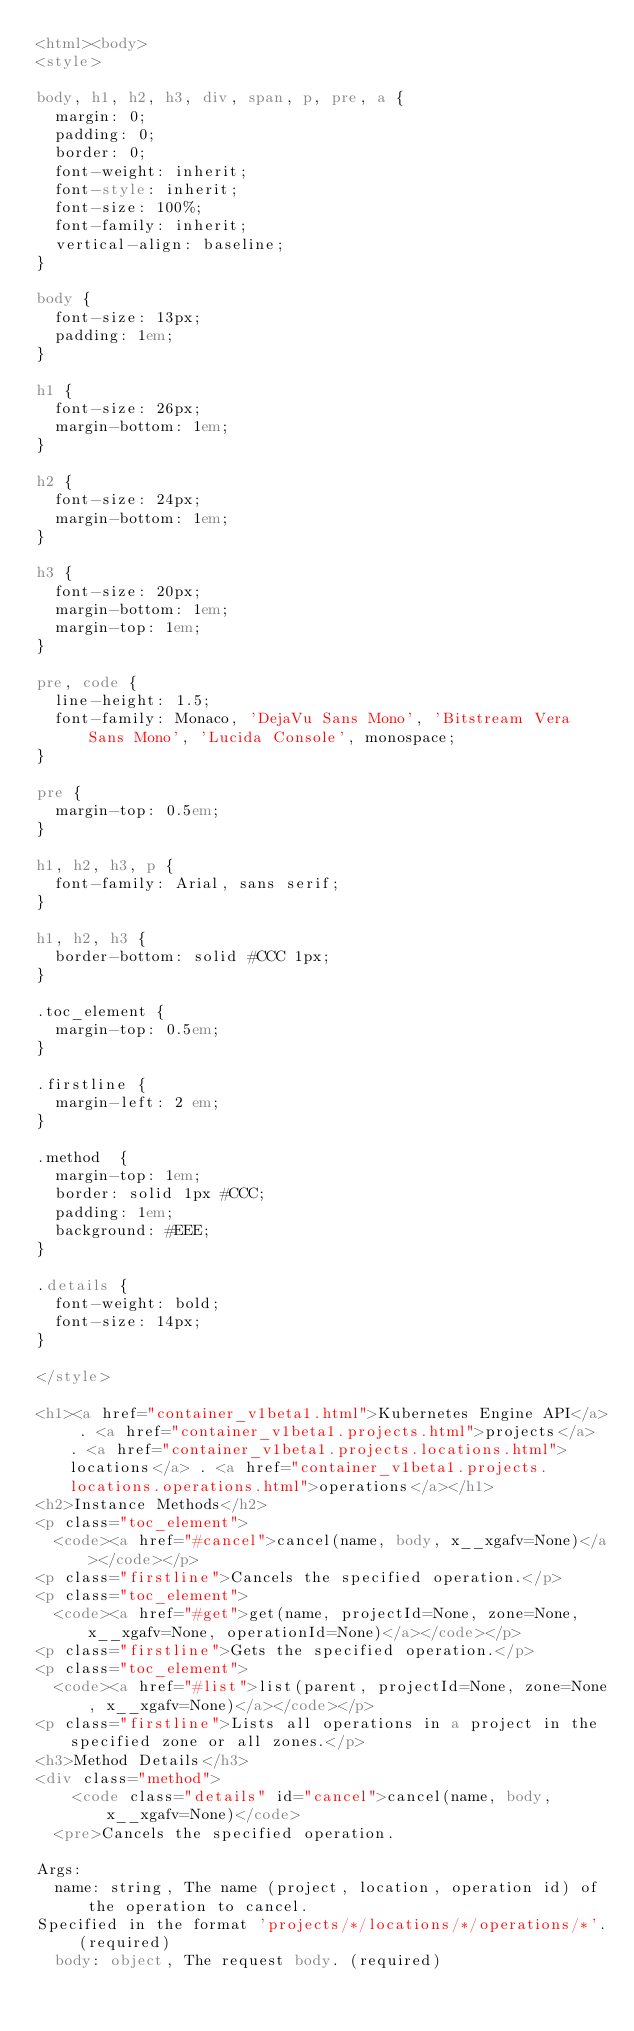Convert code to text. <code><loc_0><loc_0><loc_500><loc_500><_HTML_><html><body>
<style>

body, h1, h2, h3, div, span, p, pre, a {
  margin: 0;
  padding: 0;
  border: 0;
  font-weight: inherit;
  font-style: inherit;
  font-size: 100%;
  font-family: inherit;
  vertical-align: baseline;
}

body {
  font-size: 13px;
  padding: 1em;
}

h1 {
  font-size: 26px;
  margin-bottom: 1em;
}

h2 {
  font-size: 24px;
  margin-bottom: 1em;
}

h3 {
  font-size: 20px;
  margin-bottom: 1em;
  margin-top: 1em;
}

pre, code {
  line-height: 1.5;
  font-family: Monaco, 'DejaVu Sans Mono', 'Bitstream Vera Sans Mono', 'Lucida Console', monospace;
}

pre {
  margin-top: 0.5em;
}

h1, h2, h3, p {
  font-family: Arial, sans serif;
}

h1, h2, h3 {
  border-bottom: solid #CCC 1px;
}

.toc_element {
  margin-top: 0.5em;
}

.firstline {
  margin-left: 2 em;
}

.method  {
  margin-top: 1em;
  border: solid 1px #CCC;
  padding: 1em;
  background: #EEE;
}

.details {
  font-weight: bold;
  font-size: 14px;
}

</style>

<h1><a href="container_v1beta1.html">Kubernetes Engine API</a> . <a href="container_v1beta1.projects.html">projects</a> . <a href="container_v1beta1.projects.locations.html">locations</a> . <a href="container_v1beta1.projects.locations.operations.html">operations</a></h1>
<h2>Instance Methods</h2>
<p class="toc_element">
  <code><a href="#cancel">cancel(name, body, x__xgafv=None)</a></code></p>
<p class="firstline">Cancels the specified operation.</p>
<p class="toc_element">
  <code><a href="#get">get(name, projectId=None, zone=None, x__xgafv=None, operationId=None)</a></code></p>
<p class="firstline">Gets the specified operation.</p>
<p class="toc_element">
  <code><a href="#list">list(parent, projectId=None, zone=None, x__xgafv=None)</a></code></p>
<p class="firstline">Lists all operations in a project in the specified zone or all zones.</p>
<h3>Method Details</h3>
<div class="method">
    <code class="details" id="cancel">cancel(name, body, x__xgafv=None)</code>
  <pre>Cancels the specified operation.

Args:
  name: string, The name (project, location, operation id) of the operation to cancel.
Specified in the format 'projects/*/locations/*/operations/*'. (required)
  body: object, The request body. (required)</code> 